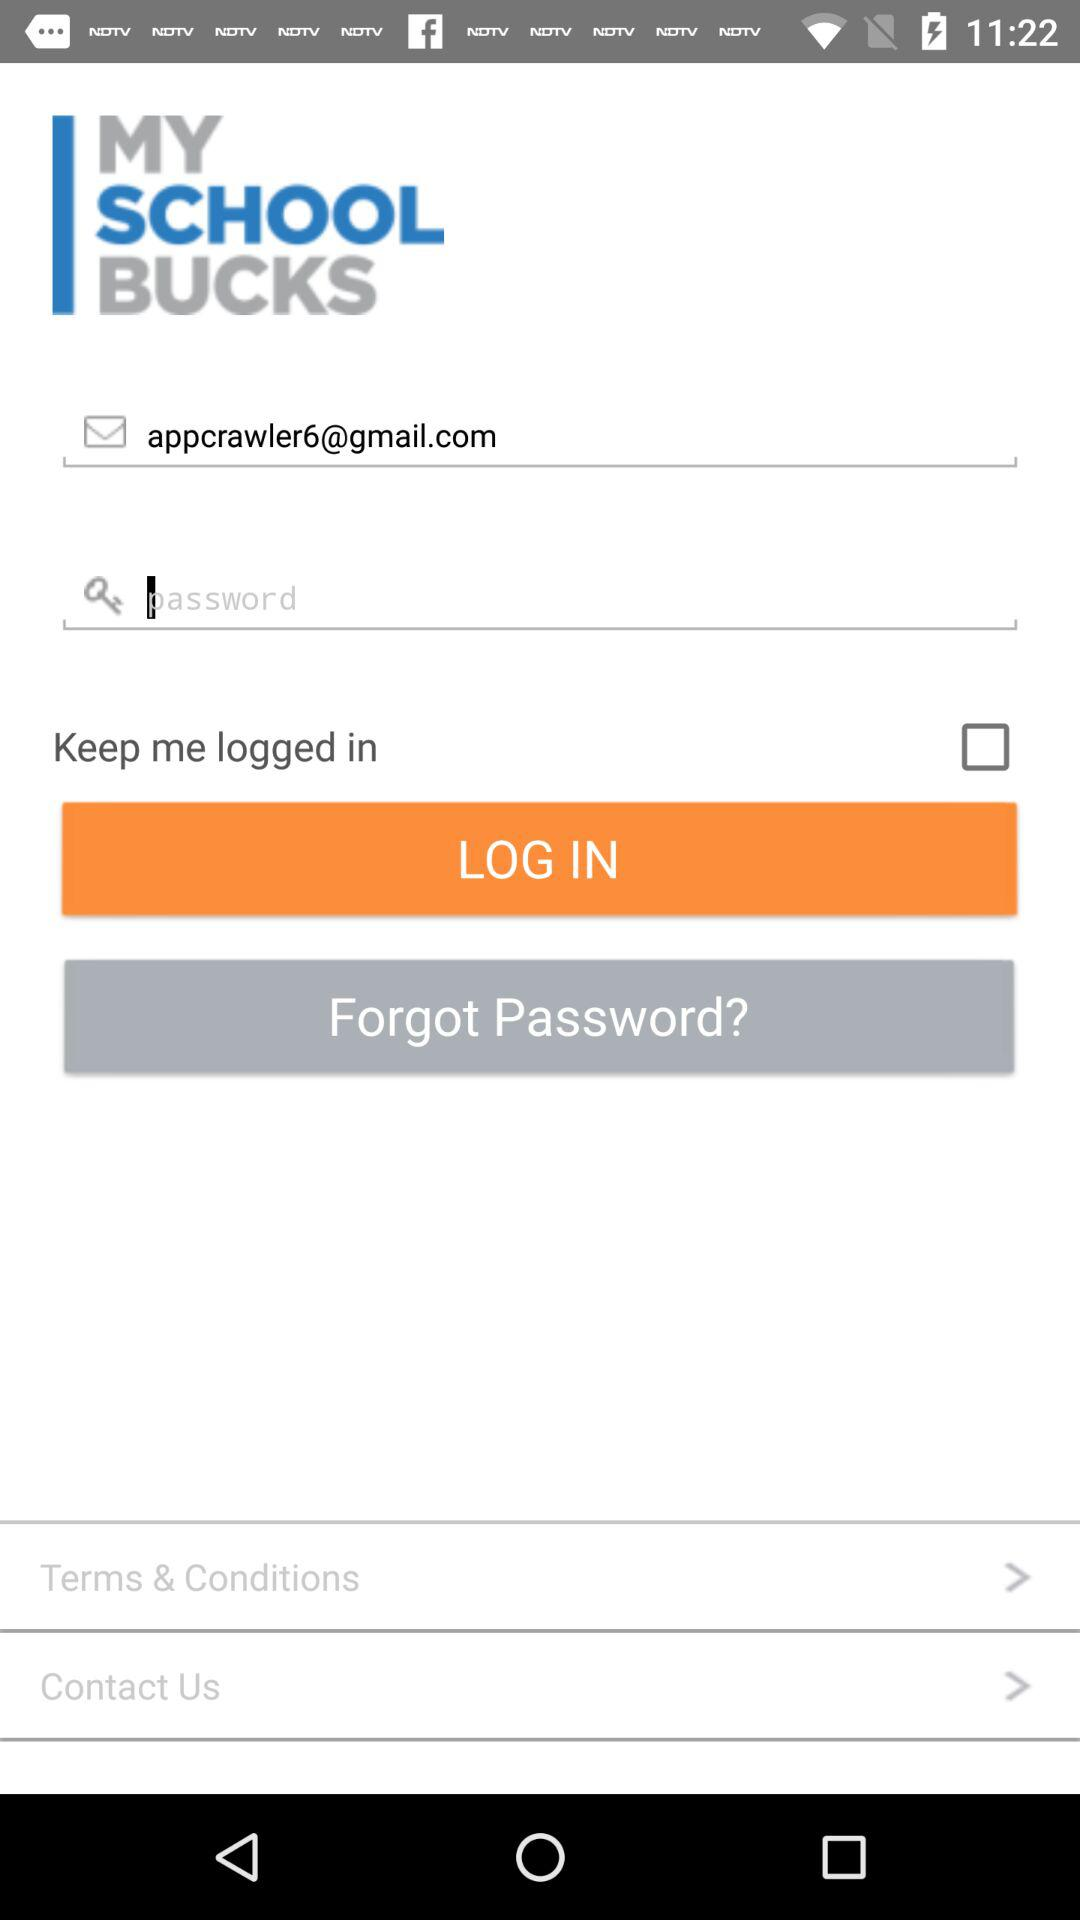What is the name of the application? The name of the application is "MySchoolBucks". 